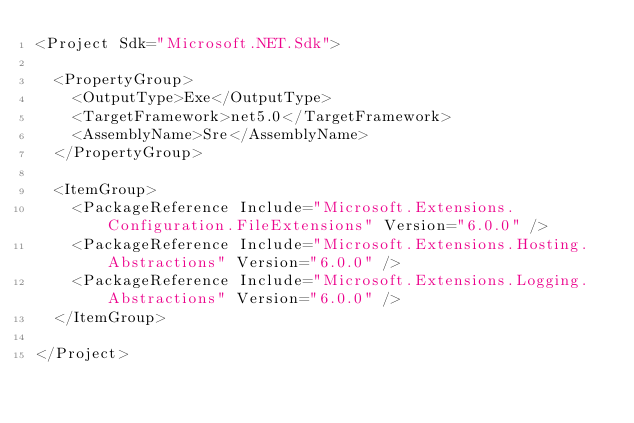<code> <loc_0><loc_0><loc_500><loc_500><_XML_><Project Sdk="Microsoft.NET.Sdk">

  <PropertyGroup>
    <OutputType>Exe</OutputType>
    <TargetFramework>net5.0</TargetFramework>
    <AssemblyName>Sre</AssemblyName>
  </PropertyGroup>

  <ItemGroup>
    <PackageReference Include="Microsoft.Extensions.Configuration.FileExtensions" Version="6.0.0" />
    <PackageReference Include="Microsoft.Extensions.Hosting.Abstractions" Version="6.0.0" />
    <PackageReference Include="Microsoft.Extensions.Logging.Abstractions" Version="6.0.0" />
  </ItemGroup>

</Project>
</code> 